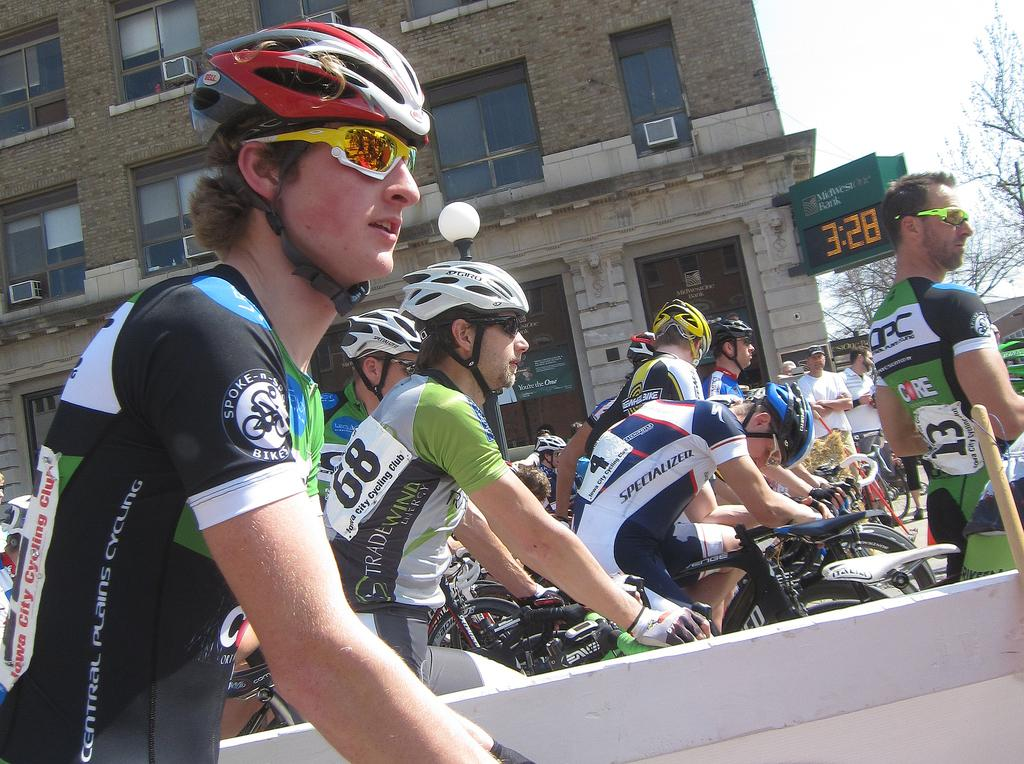How many persons are in the image? There are persons in the image, but the exact number is not specified. What type of clothing are the persons wearing? The persons are wearing sports dress. What protective gear are the persons wearing? The persons are wearing helmets. What activity are the persons engaged in? The persons are riding bicycles. What can be seen in the background of the image? There is a building and trees in the background of the image. What is the condition of the sky in the image? The sky is clear in the image. What type of hook can be seen hanging from the building in the image? There is no hook present in the image; only the persons riding bicycles, their clothing, helmets, and the background elements are visible. 